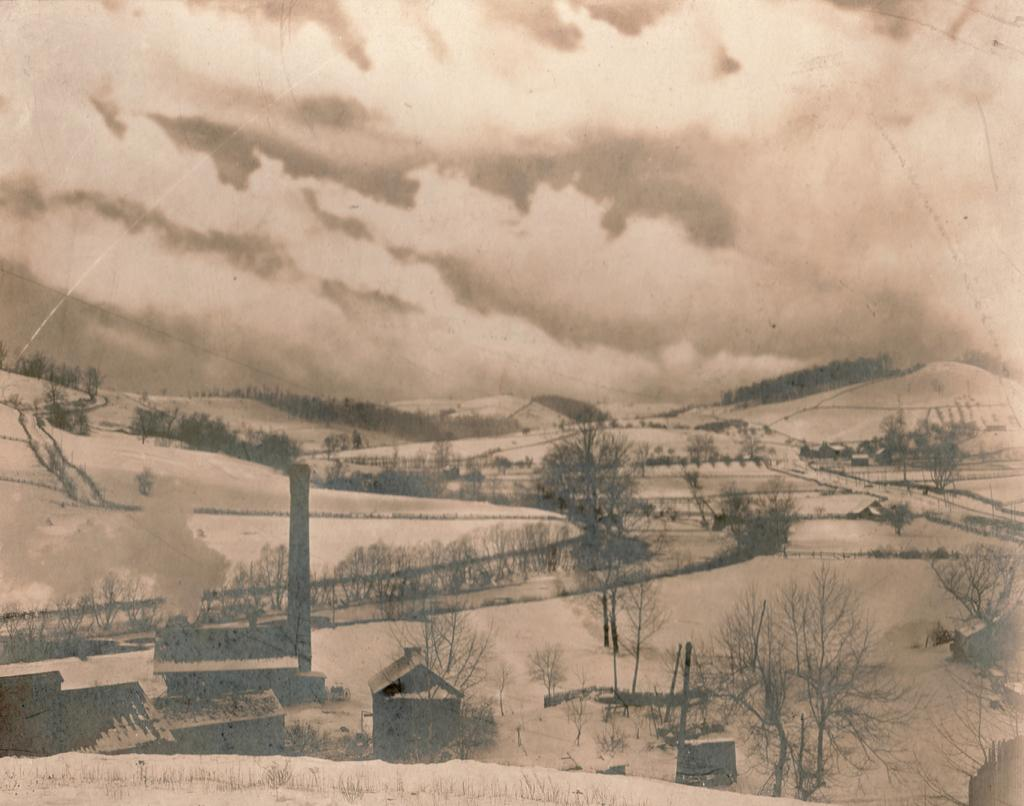What is depicted in the painting in the image? There is a painting of houses and trees in the image. What type of surface can be seen in the image? There is sand visible in the image. What is the boundary between the sand and the painting? There is a fence in the image. What is visible at the top of the image? The sky is visible at the top of the image. What can be observed in the sky? Clouds are present in the sky. How far away is the throat from the sand in the image? There is no throat present in the image, as it is a painting of houses and trees with sand and a fence. 